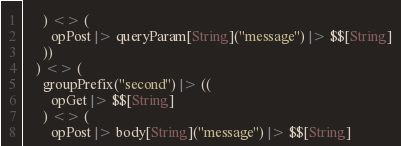Convert code to text. <code><loc_0><loc_0><loc_500><loc_500><_Scala_>      ) <> (
        opPost |> queryParam[String]("message") |> $$[String]
      ))
    ) <> (
      groupPrefix("second") |> ((
        opGet |> $$[String]
      ) <> (
        opPost |> body[String]("message") |> $$[String]</code> 